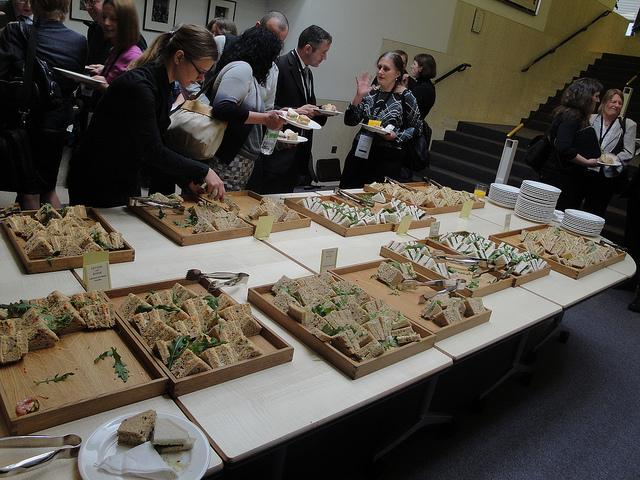What color are the plates?
Concise answer only. White. Is this food healthy?
Concise answer only. Yes. Are there pieces on the game board?
Write a very short answer. No. What color is the table?
Be succinct. White. Is this a kitchen?
Short answer required. No. What kind of food is on the table?
Quick response, please. Sandwiches. How many trays of food?
Keep it brief. 15. What is under the pizza box?
Give a very brief answer. Table. What type of food is in the box?
Short answer required. Sandwiches. Is the man young?
Concise answer only. No. Is there anything chocolate in this photo?
Concise answer only. No. What is being sold?
Concise answer only. Sandwiches. Where is this picture taken?
Quick response, please. Inside. What kind of sandwiches are those?
Quick response, please. Finger sandwiches. What type of business is this?
Answer briefly. Catering. 